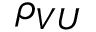<formula> <loc_0><loc_0><loc_500><loc_500>\rho _ { V U }</formula> 